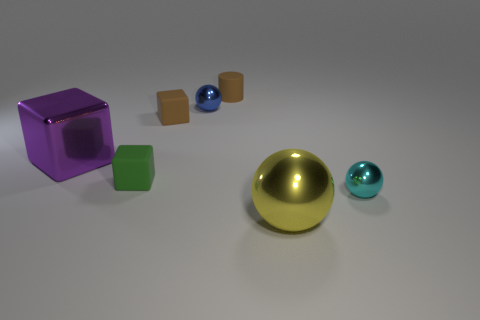Can you describe the texture and color of the hemisphere? The hemisphere has a smooth, metallic texture and sports a rich golden color.  What about the hemisphere's size compared to the other objects? The golden hemisphere is the largest object in the image when compared to the cubes and spheres. 